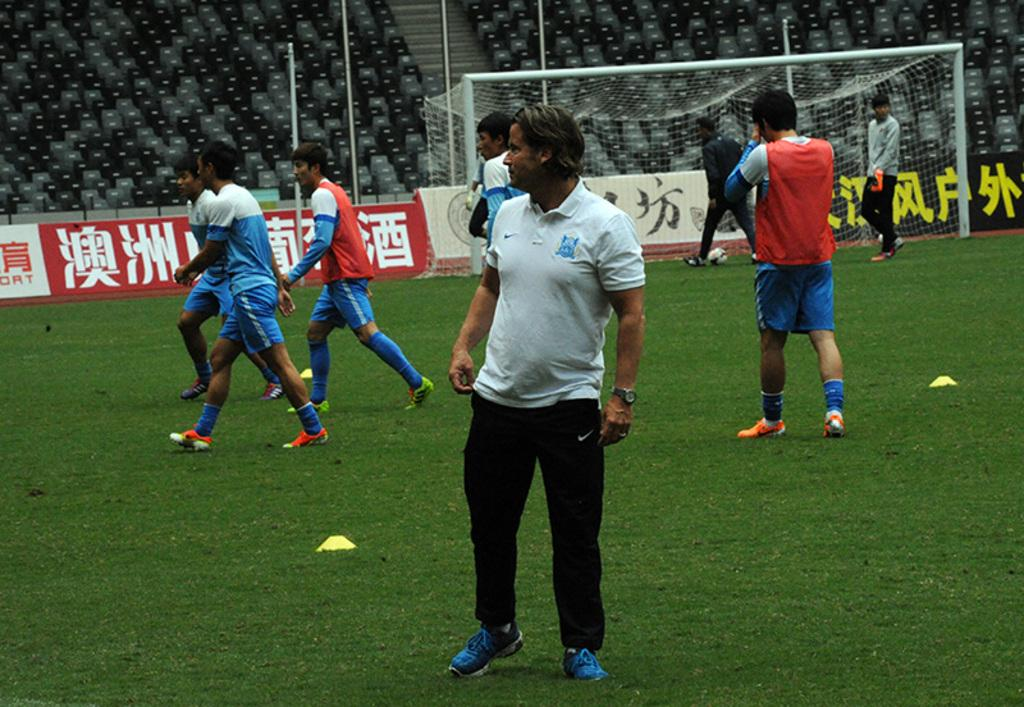What is happening on the ground in the image? There are people on the ground in the image. What structures can be seen in the image? There are poles, chairs, a net, and a staircase in the image. What objects have text on them in the image? There are boards with text in the image. What type of design can be seen on the potato in the image? There is no potato present in the image, so no design can be observed. How does the comb help the people in the image? There is no comb present in the image, so its function cannot be determined. 